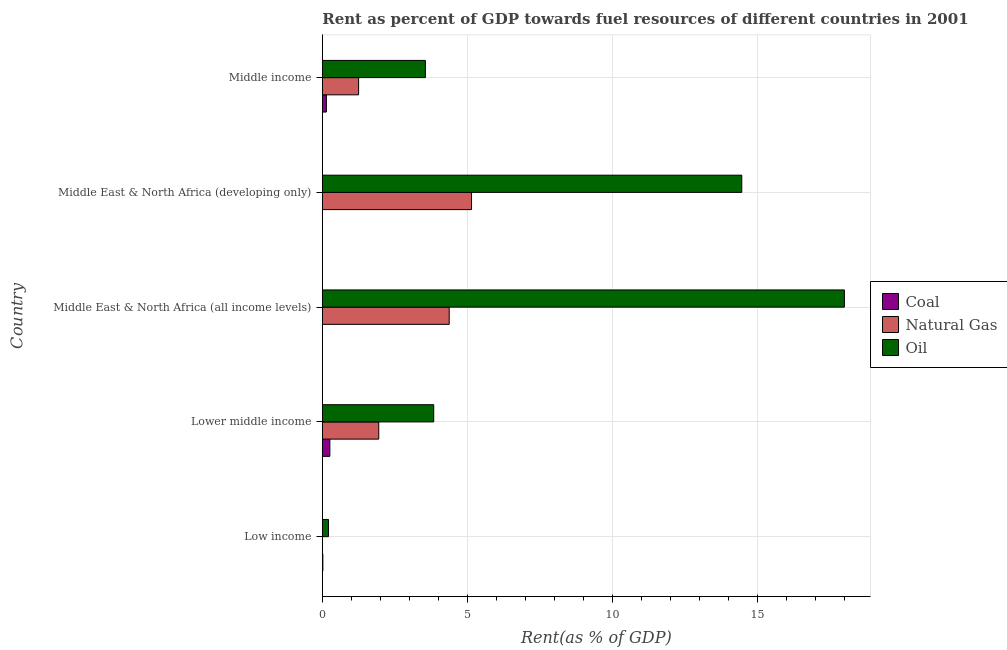Are the number of bars on each tick of the Y-axis equal?
Offer a terse response. Yes. How many bars are there on the 1st tick from the top?
Your response must be concise. 3. How many bars are there on the 4th tick from the bottom?
Your answer should be compact. 3. What is the label of the 4th group of bars from the top?
Provide a succinct answer. Lower middle income. What is the rent towards natural gas in Middle East & North Africa (developing only)?
Ensure brevity in your answer.  5.15. Across all countries, what is the maximum rent towards oil?
Provide a succinct answer. 18.01. Across all countries, what is the minimum rent towards oil?
Provide a short and direct response. 0.21. In which country was the rent towards coal maximum?
Your answer should be compact. Lower middle income. In which country was the rent towards coal minimum?
Make the answer very short. Middle East & North Africa (all income levels). What is the total rent towards oil in the graph?
Offer a very short reply. 40.08. What is the difference between the rent towards oil in Lower middle income and that in Middle East & North Africa (developing only)?
Keep it short and to the point. -10.62. What is the difference between the rent towards natural gas in Middle East & North Africa (all income levels) and the rent towards coal in Middle East & North Africa (developing only)?
Make the answer very short. 4.37. What is the average rent towards oil per country?
Provide a short and direct response. 8.02. What is the difference between the rent towards coal and rent towards oil in Middle East & North Africa (all income levels)?
Ensure brevity in your answer.  -18. What is the ratio of the rent towards oil in Low income to that in Lower middle income?
Provide a short and direct response. 0.06. Is the rent towards natural gas in Low income less than that in Middle East & North Africa (all income levels)?
Provide a short and direct response. Yes. Is the difference between the rent towards natural gas in Low income and Lower middle income greater than the difference between the rent towards oil in Low income and Lower middle income?
Your answer should be compact. Yes. What is the difference between the highest and the second highest rent towards oil?
Ensure brevity in your answer.  3.54. What is the difference between the highest and the lowest rent towards coal?
Provide a succinct answer. 0.26. In how many countries, is the rent towards coal greater than the average rent towards coal taken over all countries?
Your answer should be very brief. 2. Is the sum of the rent towards coal in Middle East & North Africa (all income levels) and Middle income greater than the maximum rent towards oil across all countries?
Make the answer very short. No. What does the 3rd bar from the top in Lower middle income represents?
Give a very brief answer. Coal. What does the 1st bar from the bottom in Low income represents?
Provide a short and direct response. Coal. Are all the bars in the graph horizontal?
Provide a short and direct response. Yes. What is the difference between two consecutive major ticks on the X-axis?
Keep it short and to the point. 5. Are the values on the major ticks of X-axis written in scientific E-notation?
Ensure brevity in your answer.  No. Does the graph contain any zero values?
Give a very brief answer. No. Does the graph contain grids?
Offer a very short reply. Yes. How many legend labels are there?
Provide a short and direct response. 3. What is the title of the graph?
Offer a terse response. Rent as percent of GDP towards fuel resources of different countries in 2001. What is the label or title of the X-axis?
Your answer should be very brief. Rent(as % of GDP). What is the label or title of the Y-axis?
Provide a succinct answer. Country. What is the Rent(as % of GDP) in Coal in Low income?
Offer a very short reply. 0.02. What is the Rent(as % of GDP) in Natural Gas in Low income?
Keep it short and to the point. 0.01. What is the Rent(as % of GDP) of Oil in Low income?
Make the answer very short. 0.21. What is the Rent(as % of GDP) in Coal in Lower middle income?
Ensure brevity in your answer.  0.26. What is the Rent(as % of GDP) of Natural Gas in Lower middle income?
Your answer should be compact. 1.95. What is the Rent(as % of GDP) of Oil in Lower middle income?
Your answer should be compact. 3.84. What is the Rent(as % of GDP) in Coal in Middle East & North Africa (all income levels)?
Provide a short and direct response. 0. What is the Rent(as % of GDP) in Natural Gas in Middle East & North Africa (all income levels)?
Offer a very short reply. 4.38. What is the Rent(as % of GDP) of Oil in Middle East & North Africa (all income levels)?
Ensure brevity in your answer.  18.01. What is the Rent(as % of GDP) of Coal in Middle East & North Africa (developing only)?
Keep it short and to the point. 0. What is the Rent(as % of GDP) of Natural Gas in Middle East & North Africa (developing only)?
Keep it short and to the point. 5.15. What is the Rent(as % of GDP) of Oil in Middle East & North Africa (developing only)?
Your response must be concise. 14.47. What is the Rent(as % of GDP) in Coal in Middle income?
Keep it short and to the point. 0.14. What is the Rent(as % of GDP) of Natural Gas in Middle income?
Make the answer very short. 1.25. What is the Rent(as % of GDP) of Oil in Middle income?
Your answer should be compact. 3.55. Across all countries, what is the maximum Rent(as % of GDP) in Coal?
Your response must be concise. 0.26. Across all countries, what is the maximum Rent(as % of GDP) in Natural Gas?
Keep it short and to the point. 5.15. Across all countries, what is the maximum Rent(as % of GDP) of Oil?
Keep it short and to the point. 18.01. Across all countries, what is the minimum Rent(as % of GDP) of Coal?
Keep it short and to the point. 0. Across all countries, what is the minimum Rent(as % of GDP) of Natural Gas?
Your response must be concise. 0.01. Across all countries, what is the minimum Rent(as % of GDP) of Oil?
Offer a very short reply. 0.21. What is the total Rent(as % of GDP) in Coal in the graph?
Your response must be concise. 0.42. What is the total Rent(as % of GDP) of Natural Gas in the graph?
Provide a short and direct response. 12.73. What is the total Rent(as % of GDP) in Oil in the graph?
Your answer should be very brief. 40.08. What is the difference between the Rent(as % of GDP) of Coal in Low income and that in Lower middle income?
Give a very brief answer. -0.24. What is the difference between the Rent(as % of GDP) in Natural Gas in Low income and that in Lower middle income?
Offer a terse response. -1.94. What is the difference between the Rent(as % of GDP) of Oil in Low income and that in Lower middle income?
Make the answer very short. -3.63. What is the difference between the Rent(as % of GDP) of Coal in Low income and that in Middle East & North Africa (all income levels)?
Offer a terse response. 0.02. What is the difference between the Rent(as % of GDP) in Natural Gas in Low income and that in Middle East & North Africa (all income levels)?
Offer a terse response. -4.37. What is the difference between the Rent(as % of GDP) in Oil in Low income and that in Middle East & North Africa (all income levels)?
Offer a very short reply. -17.79. What is the difference between the Rent(as % of GDP) of Coal in Low income and that in Middle East & North Africa (developing only)?
Keep it short and to the point. 0.01. What is the difference between the Rent(as % of GDP) in Natural Gas in Low income and that in Middle East & North Africa (developing only)?
Provide a short and direct response. -5.14. What is the difference between the Rent(as % of GDP) in Oil in Low income and that in Middle East & North Africa (developing only)?
Provide a short and direct response. -14.26. What is the difference between the Rent(as % of GDP) of Coal in Low income and that in Middle income?
Your answer should be compact. -0.12. What is the difference between the Rent(as % of GDP) of Natural Gas in Low income and that in Middle income?
Your answer should be compact. -1.25. What is the difference between the Rent(as % of GDP) of Oil in Low income and that in Middle income?
Provide a succinct answer. -3.34. What is the difference between the Rent(as % of GDP) of Coal in Lower middle income and that in Middle East & North Africa (all income levels)?
Your answer should be compact. 0.26. What is the difference between the Rent(as % of GDP) of Natural Gas in Lower middle income and that in Middle East & North Africa (all income levels)?
Make the answer very short. -2.43. What is the difference between the Rent(as % of GDP) in Oil in Lower middle income and that in Middle East & North Africa (all income levels)?
Give a very brief answer. -14.16. What is the difference between the Rent(as % of GDP) in Coal in Lower middle income and that in Middle East & North Africa (developing only)?
Provide a succinct answer. 0.26. What is the difference between the Rent(as % of GDP) in Natural Gas in Lower middle income and that in Middle East & North Africa (developing only)?
Make the answer very short. -3.2. What is the difference between the Rent(as % of GDP) in Oil in Lower middle income and that in Middle East & North Africa (developing only)?
Your response must be concise. -10.63. What is the difference between the Rent(as % of GDP) of Coal in Lower middle income and that in Middle income?
Provide a succinct answer. 0.12. What is the difference between the Rent(as % of GDP) of Natural Gas in Lower middle income and that in Middle income?
Provide a succinct answer. 0.69. What is the difference between the Rent(as % of GDP) in Oil in Lower middle income and that in Middle income?
Your answer should be very brief. 0.29. What is the difference between the Rent(as % of GDP) of Coal in Middle East & North Africa (all income levels) and that in Middle East & North Africa (developing only)?
Provide a short and direct response. -0. What is the difference between the Rent(as % of GDP) of Natural Gas in Middle East & North Africa (all income levels) and that in Middle East & North Africa (developing only)?
Your answer should be compact. -0.77. What is the difference between the Rent(as % of GDP) of Oil in Middle East & North Africa (all income levels) and that in Middle East & North Africa (developing only)?
Give a very brief answer. 3.54. What is the difference between the Rent(as % of GDP) of Coal in Middle East & North Africa (all income levels) and that in Middle income?
Provide a short and direct response. -0.14. What is the difference between the Rent(as % of GDP) of Natural Gas in Middle East & North Africa (all income levels) and that in Middle income?
Give a very brief answer. 3.12. What is the difference between the Rent(as % of GDP) in Oil in Middle East & North Africa (all income levels) and that in Middle income?
Your response must be concise. 14.45. What is the difference between the Rent(as % of GDP) in Coal in Middle East & North Africa (developing only) and that in Middle income?
Your response must be concise. -0.14. What is the difference between the Rent(as % of GDP) in Natural Gas in Middle East & North Africa (developing only) and that in Middle income?
Keep it short and to the point. 3.89. What is the difference between the Rent(as % of GDP) of Oil in Middle East & North Africa (developing only) and that in Middle income?
Your response must be concise. 10.91. What is the difference between the Rent(as % of GDP) of Coal in Low income and the Rent(as % of GDP) of Natural Gas in Lower middle income?
Offer a very short reply. -1.93. What is the difference between the Rent(as % of GDP) in Coal in Low income and the Rent(as % of GDP) in Oil in Lower middle income?
Keep it short and to the point. -3.82. What is the difference between the Rent(as % of GDP) of Natural Gas in Low income and the Rent(as % of GDP) of Oil in Lower middle income?
Offer a terse response. -3.84. What is the difference between the Rent(as % of GDP) of Coal in Low income and the Rent(as % of GDP) of Natural Gas in Middle East & North Africa (all income levels)?
Provide a succinct answer. -4.36. What is the difference between the Rent(as % of GDP) of Coal in Low income and the Rent(as % of GDP) of Oil in Middle East & North Africa (all income levels)?
Your response must be concise. -17.99. What is the difference between the Rent(as % of GDP) in Natural Gas in Low income and the Rent(as % of GDP) in Oil in Middle East & North Africa (all income levels)?
Keep it short and to the point. -18. What is the difference between the Rent(as % of GDP) of Coal in Low income and the Rent(as % of GDP) of Natural Gas in Middle East & North Africa (developing only)?
Offer a terse response. -5.13. What is the difference between the Rent(as % of GDP) of Coal in Low income and the Rent(as % of GDP) of Oil in Middle East & North Africa (developing only)?
Your answer should be very brief. -14.45. What is the difference between the Rent(as % of GDP) in Natural Gas in Low income and the Rent(as % of GDP) in Oil in Middle East & North Africa (developing only)?
Offer a terse response. -14.46. What is the difference between the Rent(as % of GDP) of Coal in Low income and the Rent(as % of GDP) of Natural Gas in Middle income?
Your response must be concise. -1.23. What is the difference between the Rent(as % of GDP) in Coal in Low income and the Rent(as % of GDP) in Oil in Middle income?
Your response must be concise. -3.54. What is the difference between the Rent(as % of GDP) of Natural Gas in Low income and the Rent(as % of GDP) of Oil in Middle income?
Provide a short and direct response. -3.55. What is the difference between the Rent(as % of GDP) in Coal in Lower middle income and the Rent(as % of GDP) in Natural Gas in Middle East & North Africa (all income levels)?
Ensure brevity in your answer.  -4.12. What is the difference between the Rent(as % of GDP) of Coal in Lower middle income and the Rent(as % of GDP) of Oil in Middle East & North Africa (all income levels)?
Your answer should be very brief. -17.75. What is the difference between the Rent(as % of GDP) in Natural Gas in Lower middle income and the Rent(as % of GDP) in Oil in Middle East & North Africa (all income levels)?
Provide a short and direct response. -16.06. What is the difference between the Rent(as % of GDP) of Coal in Lower middle income and the Rent(as % of GDP) of Natural Gas in Middle East & North Africa (developing only)?
Keep it short and to the point. -4.89. What is the difference between the Rent(as % of GDP) in Coal in Lower middle income and the Rent(as % of GDP) in Oil in Middle East & North Africa (developing only)?
Your answer should be compact. -14.21. What is the difference between the Rent(as % of GDP) of Natural Gas in Lower middle income and the Rent(as % of GDP) of Oil in Middle East & North Africa (developing only)?
Offer a terse response. -12.52. What is the difference between the Rent(as % of GDP) in Coal in Lower middle income and the Rent(as % of GDP) in Natural Gas in Middle income?
Provide a short and direct response. -0.99. What is the difference between the Rent(as % of GDP) in Coal in Lower middle income and the Rent(as % of GDP) in Oil in Middle income?
Offer a terse response. -3.29. What is the difference between the Rent(as % of GDP) in Natural Gas in Lower middle income and the Rent(as % of GDP) in Oil in Middle income?
Provide a short and direct response. -1.61. What is the difference between the Rent(as % of GDP) in Coal in Middle East & North Africa (all income levels) and the Rent(as % of GDP) in Natural Gas in Middle East & North Africa (developing only)?
Your answer should be very brief. -5.14. What is the difference between the Rent(as % of GDP) in Coal in Middle East & North Africa (all income levels) and the Rent(as % of GDP) in Oil in Middle East & North Africa (developing only)?
Keep it short and to the point. -14.47. What is the difference between the Rent(as % of GDP) in Natural Gas in Middle East & North Africa (all income levels) and the Rent(as % of GDP) in Oil in Middle East & North Africa (developing only)?
Make the answer very short. -10.09. What is the difference between the Rent(as % of GDP) in Coal in Middle East & North Africa (all income levels) and the Rent(as % of GDP) in Natural Gas in Middle income?
Your response must be concise. -1.25. What is the difference between the Rent(as % of GDP) of Coal in Middle East & North Africa (all income levels) and the Rent(as % of GDP) of Oil in Middle income?
Offer a very short reply. -3.55. What is the difference between the Rent(as % of GDP) in Natural Gas in Middle East & North Africa (all income levels) and the Rent(as % of GDP) in Oil in Middle income?
Provide a short and direct response. 0.82. What is the difference between the Rent(as % of GDP) in Coal in Middle East & North Africa (developing only) and the Rent(as % of GDP) in Natural Gas in Middle income?
Offer a terse response. -1.25. What is the difference between the Rent(as % of GDP) in Coal in Middle East & North Africa (developing only) and the Rent(as % of GDP) in Oil in Middle income?
Keep it short and to the point. -3.55. What is the difference between the Rent(as % of GDP) in Natural Gas in Middle East & North Africa (developing only) and the Rent(as % of GDP) in Oil in Middle income?
Offer a terse response. 1.59. What is the average Rent(as % of GDP) of Coal per country?
Your answer should be very brief. 0.08. What is the average Rent(as % of GDP) of Natural Gas per country?
Provide a short and direct response. 2.55. What is the average Rent(as % of GDP) in Oil per country?
Give a very brief answer. 8.02. What is the difference between the Rent(as % of GDP) in Coal and Rent(as % of GDP) in Natural Gas in Low income?
Your response must be concise. 0.01. What is the difference between the Rent(as % of GDP) in Coal and Rent(as % of GDP) in Oil in Low income?
Ensure brevity in your answer.  -0.19. What is the difference between the Rent(as % of GDP) of Natural Gas and Rent(as % of GDP) of Oil in Low income?
Keep it short and to the point. -0.21. What is the difference between the Rent(as % of GDP) in Coal and Rent(as % of GDP) in Natural Gas in Lower middle income?
Offer a very short reply. -1.69. What is the difference between the Rent(as % of GDP) of Coal and Rent(as % of GDP) of Oil in Lower middle income?
Provide a succinct answer. -3.58. What is the difference between the Rent(as % of GDP) of Natural Gas and Rent(as % of GDP) of Oil in Lower middle income?
Make the answer very short. -1.9. What is the difference between the Rent(as % of GDP) of Coal and Rent(as % of GDP) of Natural Gas in Middle East & North Africa (all income levels)?
Your response must be concise. -4.37. What is the difference between the Rent(as % of GDP) of Coal and Rent(as % of GDP) of Oil in Middle East & North Africa (all income levels)?
Provide a succinct answer. -18.01. What is the difference between the Rent(as % of GDP) of Natural Gas and Rent(as % of GDP) of Oil in Middle East & North Africa (all income levels)?
Your response must be concise. -13.63. What is the difference between the Rent(as % of GDP) of Coal and Rent(as % of GDP) of Natural Gas in Middle East & North Africa (developing only)?
Your response must be concise. -5.14. What is the difference between the Rent(as % of GDP) of Coal and Rent(as % of GDP) of Oil in Middle East & North Africa (developing only)?
Offer a very short reply. -14.46. What is the difference between the Rent(as % of GDP) in Natural Gas and Rent(as % of GDP) in Oil in Middle East & North Africa (developing only)?
Your answer should be compact. -9.32. What is the difference between the Rent(as % of GDP) of Coal and Rent(as % of GDP) of Natural Gas in Middle income?
Keep it short and to the point. -1.11. What is the difference between the Rent(as % of GDP) of Coal and Rent(as % of GDP) of Oil in Middle income?
Provide a succinct answer. -3.41. What is the difference between the Rent(as % of GDP) in Natural Gas and Rent(as % of GDP) in Oil in Middle income?
Keep it short and to the point. -2.3. What is the ratio of the Rent(as % of GDP) in Coal in Low income to that in Lower middle income?
Your answer should be compact. 0.07. What is the ratio of the Rent(as % of GDP) in Natural Gas in Low income to that in Lower middle income?
Keep it short and to the point. 0. What is the ratio of the Rent(as % of GDP) of Oil in Low income to that in Lower middle income?
Offer a very short reply. 0.06. What is the ratio of the Rent(as % of GDP) of Coal in Low income to that in Middle East & North Africa (all income levels)?
Keep it short and to the point. 12.42. What is the ratio of the Rent(as % of GDP) in Natural Gas in Low income to that in Middle East & North Africa (all income levels)?
Your answer should be compact. 0. What is the ratio of the Rent(as % of GDP) of Oil in Low income to that in Middle East & North Africa (all income levels)?
Provide a short and direct response. 0.01. What is the ratio of the Rent(as % of GDP) of Coal in Low income to that in Middle East & North Africa (developing only)?
Offer a terse response. 5.77. What is the ratio of the Rent(as % of GDP) of Natural Gas in Low income to that in Middle East & North Africa (developing only)?
Your response must be concise. 0. What is the ratio of the Rent(as % of GDP) in Oil in Low income to that in Middle East & North Africa (developing only)?
Keep it short and to the point. 0.01. What is the ratio of the Rent(as % of GDP) of Coal in Low income to that in Middle income?
Keep it short and to the point. 0.13. What is the ratio of the Rent(as % of GDP) of Natural Gas in Low income to that in Middle income?
Offer a very short reply. 0.01. What is the ratio of the Rent(as % of GDP) of Oil in Low income to that in Middle income?
Offer a very short reply. 0.06. What is the ratio of the Rent(as % of GDP) in Coal in Lower middle income to that in Middle East & North Africa (all income levels)?
Offer a terse response. 177.74. What is the ratio of the Rent(as % of GDP) of Natural Gas in Lower middle income to that in Middle East & North Africa (all income levels)?
Your response must be concise. 0.44. What is the ratio of the Rent(as % of GDP) of Oil in Lower middle income to that in Middle East & North Africa (all income levels)?
Your answer should be very brief. 0.21. What is the ratio of the Rent(as % of GDP) of Coal in Lower middle income to that in Middle East & North Africa (developing only)?
Give a very brief answer. 82.56. What is the ratio of the Rent(as % of GDP) in Natural Gas in Lower middle income to that in Middle East & North Africa (developing only)?
Provide a succinct answer. 0.38. What is the ratio of the Rent(as % of GDP) of Oil in Lower middle income to that in Middle East & North Africa (developing only)?
Provide a succinct answer. 0.27. What is the ratio of the Rent(as % of GDP) of Coal in Lower middle income to that in Middle income?
Provide a succinct answer. 1.85. What is the ratio of the Rent(as % of GDP) in Natural Gas in Lower middle income to that in Middle income?
Your answer should be compact. 1.55. What is the ratio of the Rent(as % of GDP) of Oil in Lower middle income to that in Middle income?
Make the answer very short. 1.08. What is the ratio of the Rent(as % of GDP) in Coal in Middle East & North Africa (all income levels) to that in Middle East & North Africa (developing only)?
Offer a very short reply. 0.46. What is the ratio of the Rent(as % of GDP) in Natural Gas in Middle East & North Africa (all income levels) to that in Middle East & North Africa (developing only)?
Keep it short and to the point. 0.85. What is the ratio of the Rent(as % of GDP) of Oil in Middle East & North Africa (all income levels) to that in Middle East & North Africa (developing only)?
Make the answer very short. 1.24. What is the ratio of the Rent(as % of GDP) in Coal in Middle East & North Africa (all income levels) to that in Middle income?
Your answer should be very brief. 0.01. What is the ratio of the Rent(as % of GDP) of Natural Gas in Middle East & North Africa (all income levels) to that in Middle income?
Provide a succinct answer. 3.5. What is the ratio of the Rent(as % of GDP) in Oil in Middle East & North Africa (all income levels) to that in Middle income?
Provide a succinct answer. 5.07. What is the ratio of the Rent(as % of GDP) in Coal in Middle East & North Africa (developing only) to that in Middle income?
Make the answer very short. 0.02. What is the ratio of the Rent(as % of GDP) of Natural Gas in Middle East & North Africa (developing only) to that in Middle income?
Offer a terse response. 4.11. What is the ratio of the Rent(as % of GDP) in Oil in Middle East & North Africa (developing only) to that in Middle income?
Give a very brief answer. 4.07. What is the difference between the highest and the second highest Rent(as % of GDP) in Coal?
Your answer should be compact. 0.12. What is the difference between the highest and the second highest Rent(as % of GDP) of Natural Gas?
Give a very brief answer. 0.77. What is the difference between the highest and the second highest Rent(as % of GDP) in Oil?
Your answer should be very brief. 3.54. What is the difference between the highest and the lowest Rent(as % of GDP) of Coal?
Keep it short and to the point. 0.26. What is the difference between the highest and the lowest Rent(as % of GDP) of Natural Gas?
Ensure brevity in your answer.  5.14. What is the difference between the highest and the lowest Rent(as % of GDP) in Oil?
Ensure brevity in your answer.  17.79. 